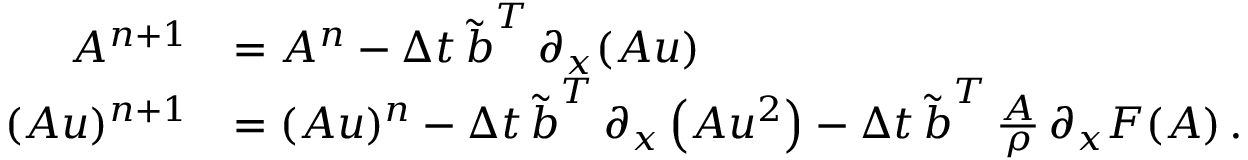Convert formula to latex. <formula><loc_0><loc_0><loc_500><loc_500>\begin{array} { r l } { A ^ { n + 1 } } & { = A ^ { n } - \Delta t \, \tilde { b } ^ { T } \, \partial _ { x } ( A u ) } \\ { ( A u ) ^ { n + 1 } } & { = ( A u ) ^ { n } - \Delta t \, \tilde { b } ^ { T } \, \partial _ { x } \left ( A u ^ { 2 } \right ) - \Delta t \, \tilde { b } ^ { T } \, \frac { A } { \rho } \, \partial _ { x } F ( A ) \, . } \end{array}</formula> 